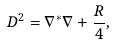Convert formula to latex. <formula><loc_0><loc_0><loc_500><loc_500>D ^ { 2 } = \nabla ^ { * } \nabla + \frac { R } { 4 } ,</formula> 